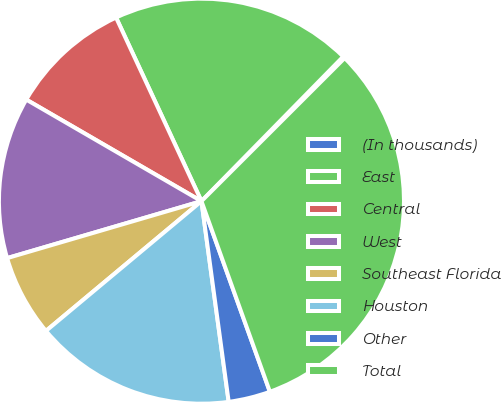<chart> <loc_0><loc_0><loc_500><loc_500><pie_chart><fcel>(In thousands)<fcel>East<fcel>Central<fcel>West<fcel>Southeast Florida<fcel>Houston<fcel>Other<fcel>Total<nl><fcel>0.16%<fcel>19.27%<fcel>9.71%<fcel>12.9%<fcel>6.53%<fcel>16.08%<fcel>3.34%<fcel>32.01%<nl></chart> 